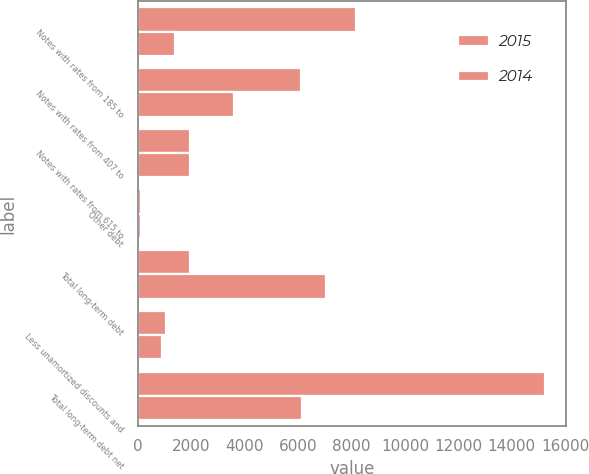<chart> <loc_0><loc_0><loc_500><loc_500><stacked_bar_chart><ecel><fcel>Notes with rates from 185 to<fcel>Notes with rates from 407 to<fcel>Notes with rates from 615 to<fcel>Other debt<fcel>Total long-term debt<fcel>Less unamortized discounts and<fcel>Total long-term debt net<nl><fcel>2015<fcel>8150<fcel>6089<fcel>1941<fcel>116<fcel>1941<fcel>1035<fcel>15261<nl><fcel>2014<fcel>1400<fcel>3589<fcel>1941<fcel>111<fcel>7041<fcel>899<fcel>6142<nl></chart> 